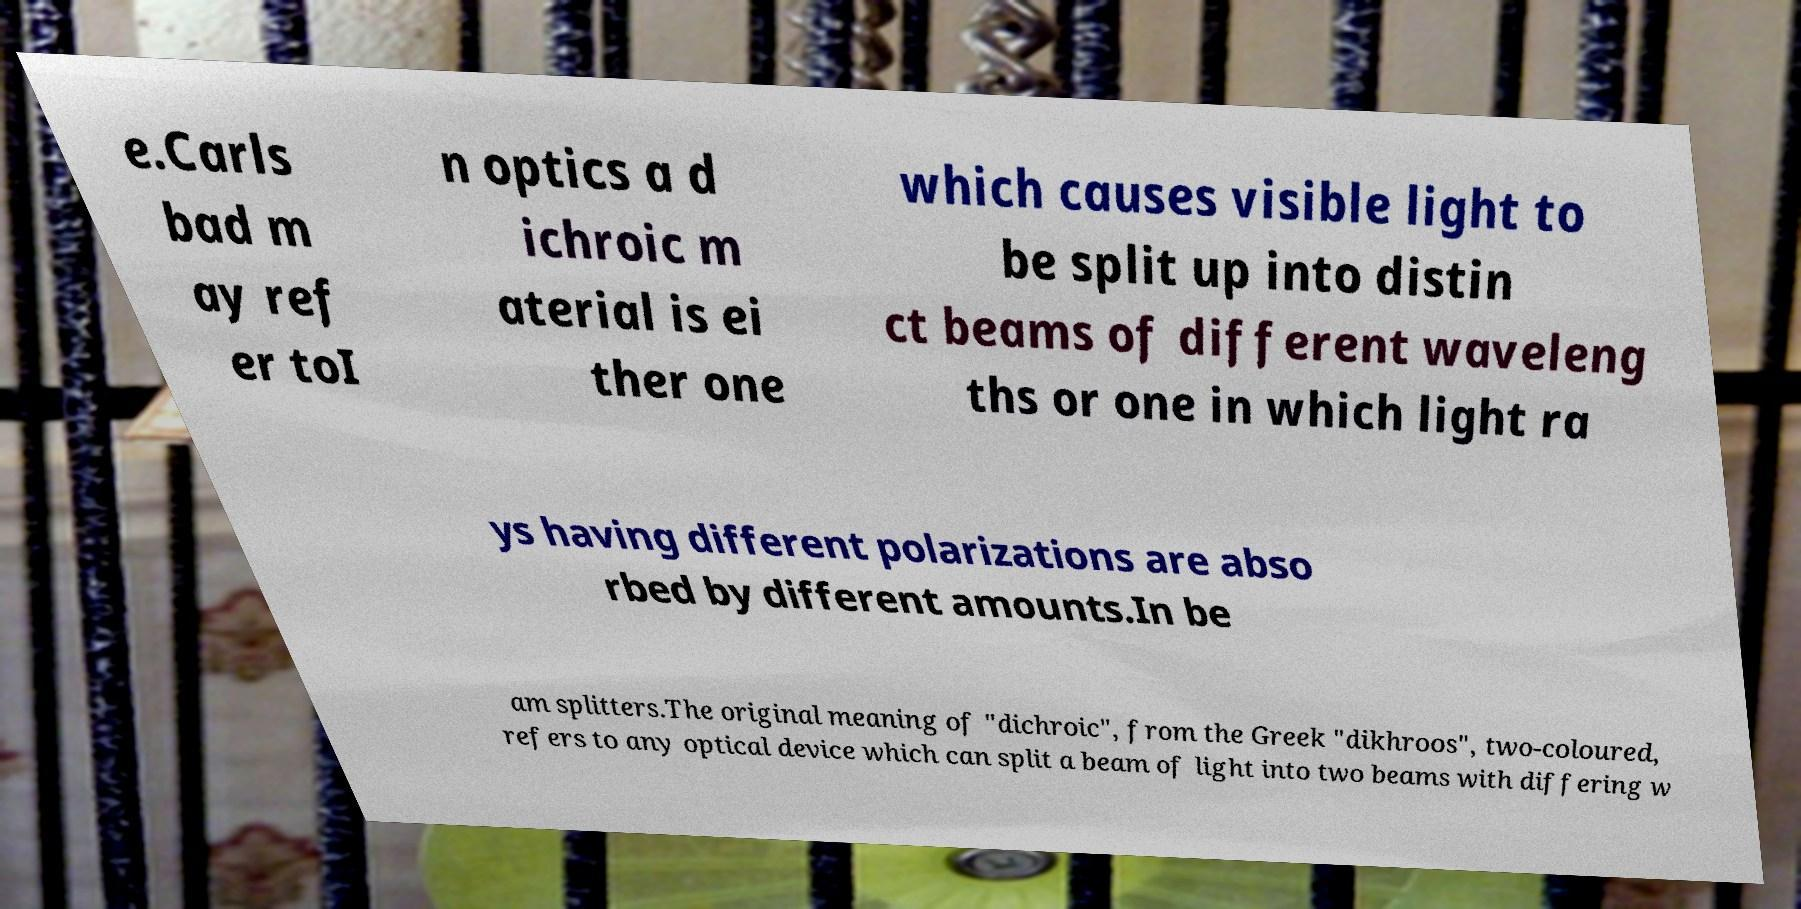Could you assist in decoding the text presented in this image and type it out clearly? e.Carls bad m ay ref er toI n optics a d ichroic m aterial is ei ther one which causes visible light to be split up into distin ct beams of different waveleng ths or one in which light ra ys having different polarizations are abso rbed by different amounts.In be am splitters.The original meaning of "dichroic", from the Greek "dikhroos", two-coloured, refers to any optical device which can split a beam of light into two beams with differing w 